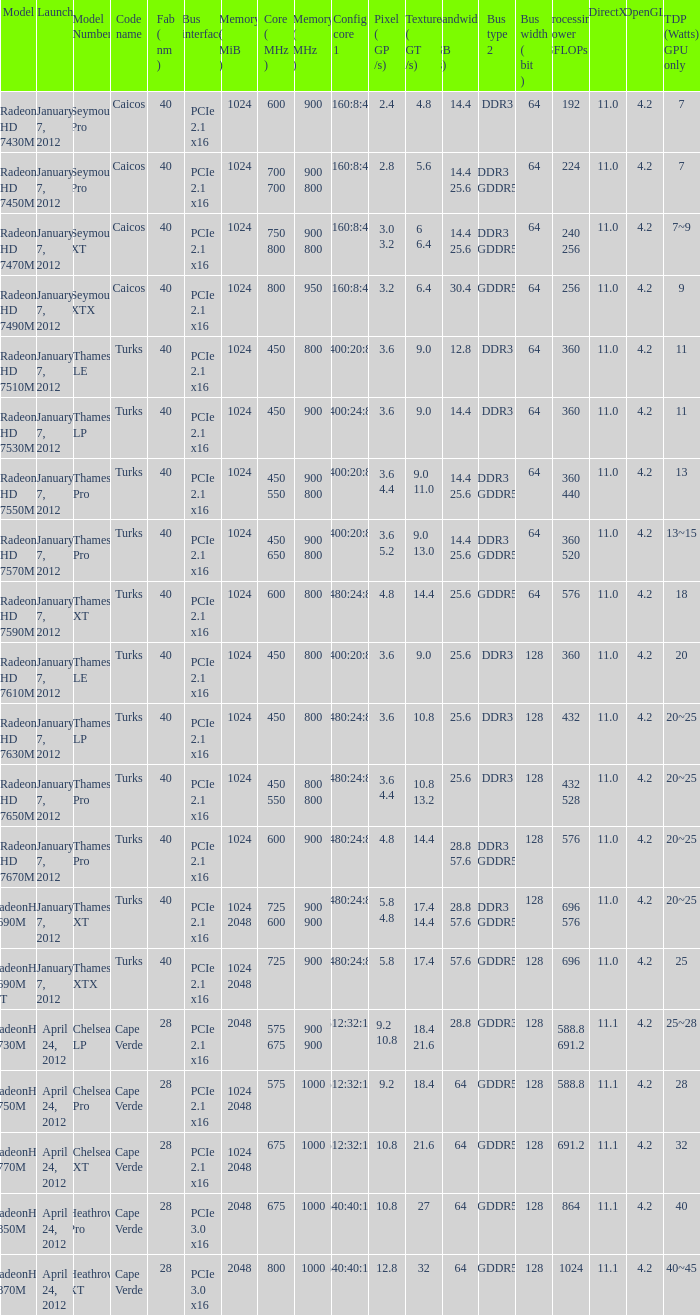What was the maximum fab (nm)? 40.0. 